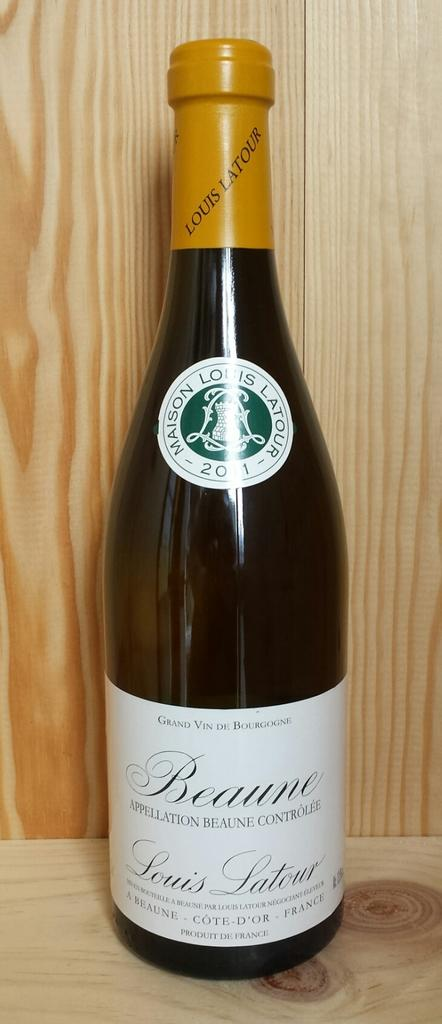<image>
Relay a brief, clear account of the picture shown. A bottle of Beaune Appellation Controlee wine from France is on a wooden shelf. 